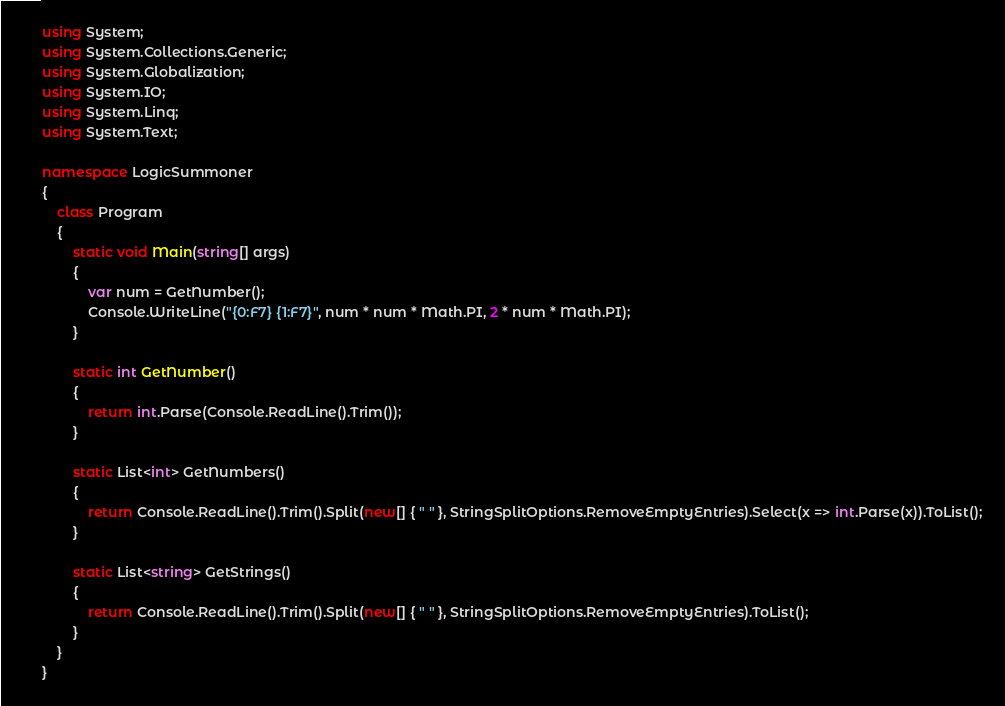Convert code to text. <code><loc_0><loc_0><loc_500><loc_500><_C#_>using System;
using System.Collections.Generic;
using System.Globalization;
using System.IO;
using System.Linq;
using System.Text;

namespace LogicSummoner
{
    class Program
    {
        static void Main(string[] args)
        {
            var num = GetNumber();
            Console.WriteLine("{0:F7} {1:F7}", num * num * Math.PI, 2 * num * Math.PI);
        }

        static int GetNumber()
        {
            return int.Parse(Console.ReadLine().Trim());
        }

        static List<int> GetNumbers()
        {
            return Console.ReadLine().Trim().Split(new[] { " " }, StringSplitOptions.RemoveEmptyEntries).Select(x => int.Parse(x)).ToList();
        }

        static List<string> GetStrings()
        {
            return Console.ReadLine().Trim().Split(new[] { " " }, StringSplitOptions.RemoveEmptyEntries).ToList();
        }
    }
}</code> 